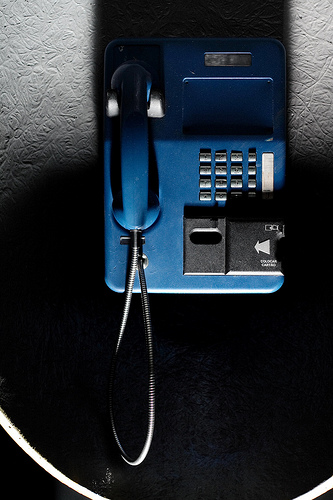<image>
Is there a phone on the wall? Yes. Looking at the image, I can see the phone is positioned on top of the wall, with the wall providing support. 